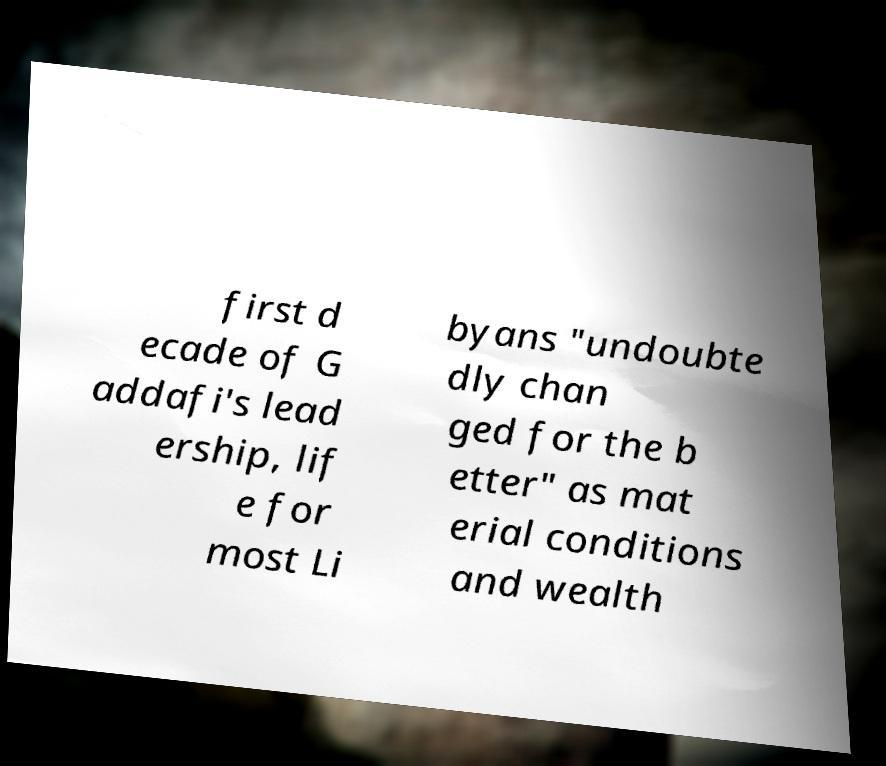Please identify and transcribe the text found in this image. first d ecade of G addafi's lead ership, lif e for most Li byans "undoubte dly chan ged for the b etter" as mat erial conditions and wealth 